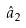Convert formula to latex. <formula><loc_0><loc_0><loc_500><loc_500>\hat { a } _ { 2 }</formula> 